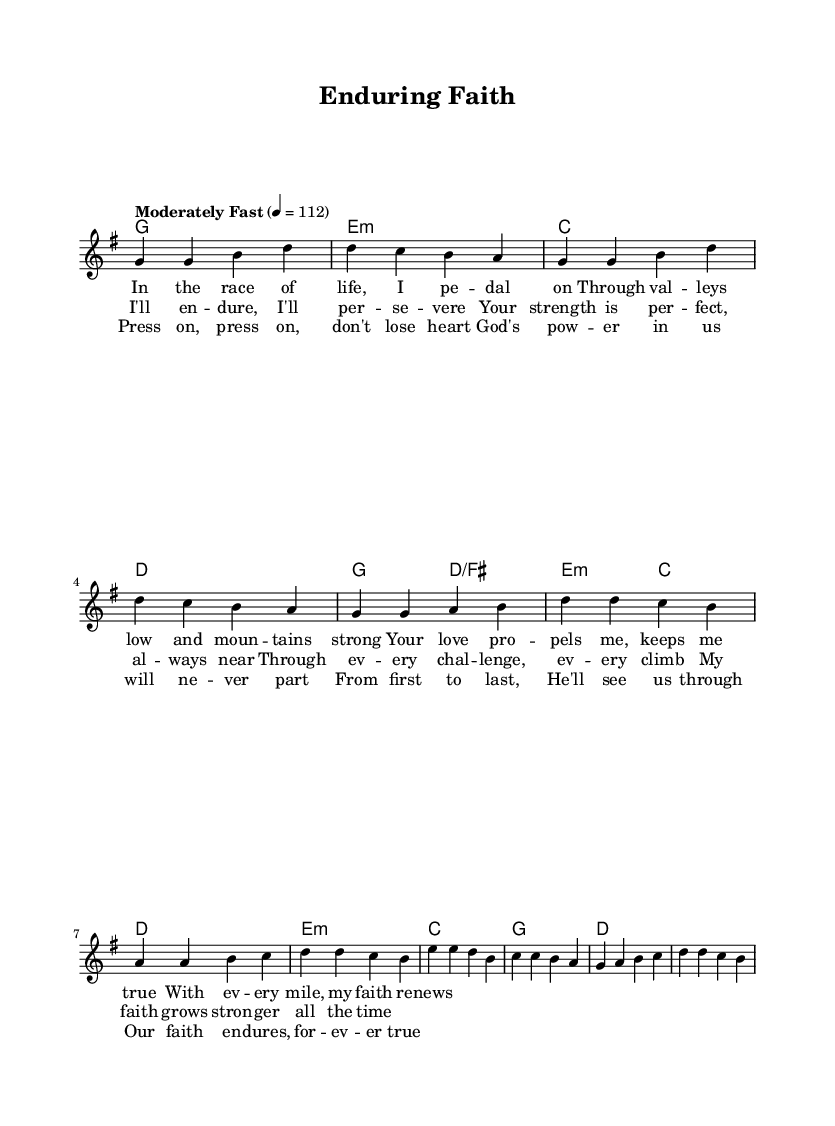What is the key signature of this music? The key signature is G major, which has one sharp note (F#). This can be identified by looking for the sharp signs located on the staff's G line, indicating that F is raised by a half step.
Answer: G major What is the time signature of this music? The time signature is 4/4, which can be determined by inspecting the notation at the beginning of the score, specifically two numbers over each other. The top number indicates there are four beats per measure, and the bottom number indicates a quarter note receives one beat.
Answer: 4/4 What is the tempo marking of this music? The tempo marking is "Moderately Fast," which indicates the pace at which the piece should be played. This is stated at the beginning of the score above the staff, accompanied by the metronome marking of 112 beats per minute.
Answer: Moderately Fast How many measures are in the verse section? The verse section contains four measures, as indicated by each grouping of notes separated by vertical lines which represent the measure bars. Counting these from the beginning of the verse lyric shows four complete measures.
Answer: 4 What is the lyrical theme of the chorus? The lyrical theme of the chorus focuses on endurance and strength in faith, emphasizing reliance on divine strength and the growth of faith through challenges. This can be gleaned from the lyrical content provided that conveys perseverance in trials.
Answer: Endurance and strength What do the lyrics of the bridge encourage the listener to do? The lyrics of the bridge encourage the listener to "press on" and not lose heart, highlighting the assurance of God's unwavering support throughout life's challenges. This is evident in phrases that speak directly to maintaining faith and determination.
Answer: Press on What type of lyrics are primarily featured in this sheet music? The lyrics primarily feature religious themes, often centered around faith, endurance, and reliance on divine strength during life's challenges. This can be inferred from the overall message and specific words used throughout the song.
Answer: Religious themes 